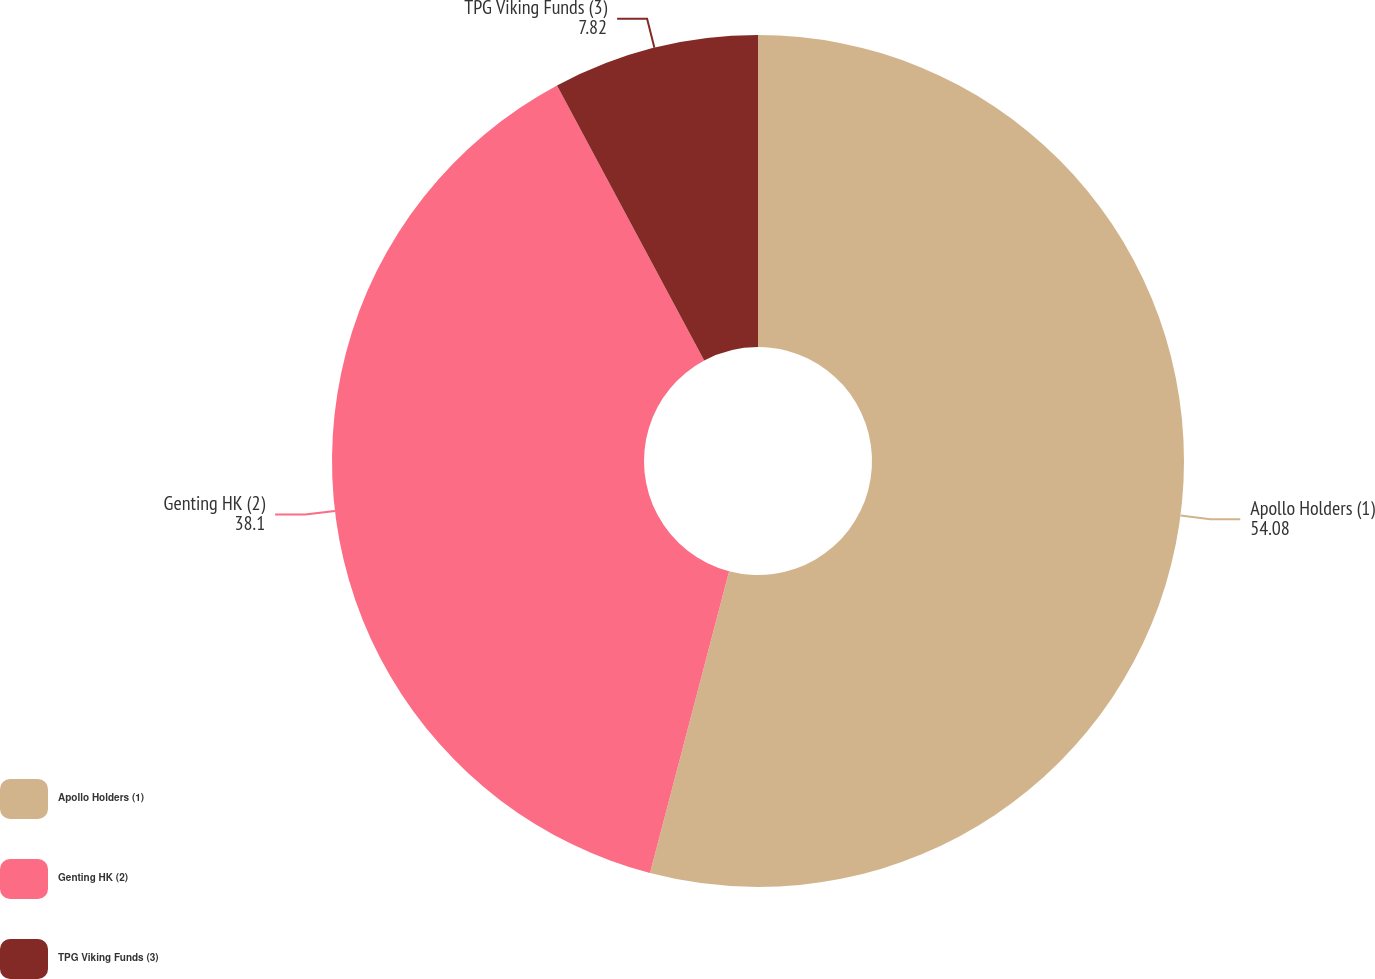Convert chart to OTSL. <chart><loc_0><loc_0><loc_500><loc_500><pie_chart><fcel>Apollo Holders (1)<fcel>Genting HK (2)<fcel>TPG Viking Funds (3)<nl><fcel>54.08%<fcel>38.1%<fcel>7.82%<nl></chart> 